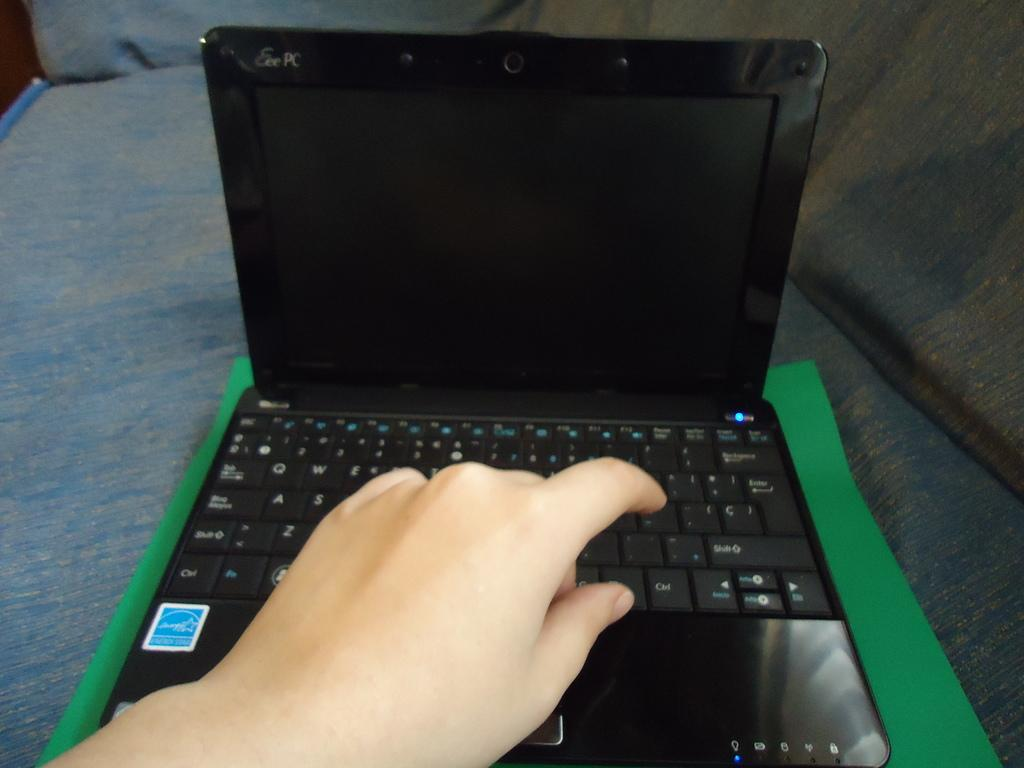<image>
Render a clear and concise summary of the photo. Someone is typing on a laptop made by Eee PC. 